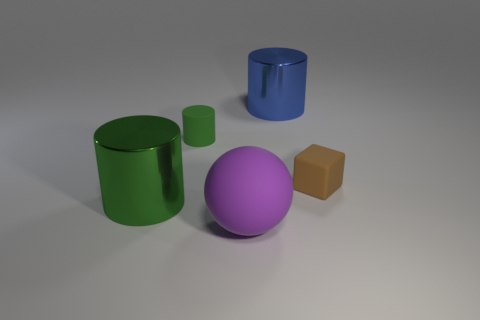Subtract all green metal cylinders. How many cylinders are left? 2 Subtract all yellow cubes. How many green cylinders are left? 2 Add 2 tiny green shiny spheres. How many objects exist? 7 Subtract all blue cylinders. How many cylinders are left? 2 Subtract all cubes. How many objects are left? 4 Subtract all large red shiny objects. Subtract all big green shiny objects. How many objects are left? 4 Add 5 big objects. How many big objects are left? 8 Add 2 small green rubber cylinders. How many small green rubber cylinders exist? 3 Subtract 0 red cylinders. How many objects are left? 5 Subtract all red spheres. Subtract all brown cubes. How many spheres are left? 1 